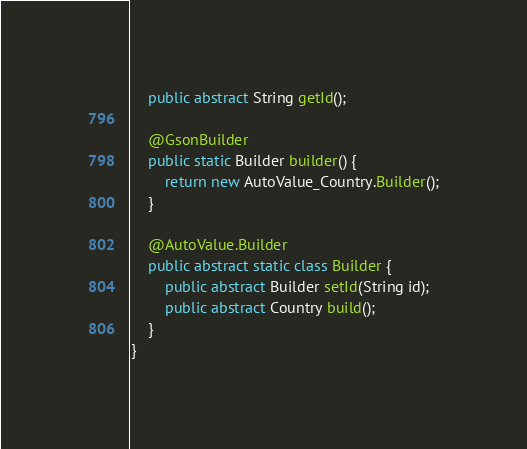<code> <loc_0><loc_0><loc_500><loc_500><_Java_>    public abstract String getId();

    @GsonBuilder
    public static Builder builder() {
        return new AutoValue_Country.Builder();
    }

    @AutoValue.Builder
    public abstract static class Builder {
        public abstract Builder setId(String id);
        public abstract Country build();
    }
}
</code> 